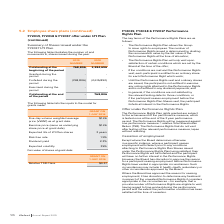According to Iselect's financial document, At which percentile will 50% of LTI Plan shares vest? Based on the financial document, the answer is 50th Percentile. Also, When will the shares vest? Based on the financial document, the answer is if a certain Total Shareholder Return (TSR) relative to the designated comparator group, being the ASX Small Ordinaries Index excluding mining and energy companies, is achieved during the performance period. Also, Which performance measure will the LTI Plans be measured against? relative Total Shareholder Return (TSR). The document states: "will be measured against one performance measure – relative Total Shareholder Return (TSR). The Performance Rights that do not vest after testing of t..." Also, can you calculate: What is the percentage change in the outstanding number of shares at the beginning of the period from 2018 to 2019? To answer this question, I need to perform calculations using the financial data. The calculation is: (768,806-3,384,696)/3,384,696, which equals -77.29 (percentage). This is based on the information: "utstanding at the beginning of the period 768,806 3,384,696 Outstanding at the beginning of the period 768,806 3,384,696..." The key data points involved are: 3,384,696, 768,806. Also, can you calculate: What is the percentage change in the number of forfeited shares during the period from 2018 to 2019? To answer this question, I need to perform calculations using the financial data. The calculation is: (768,806-2,615,890)/2,615,890, which equals -70.61 (percentage). This is based on the information: "Forfeited during the period (768,806) (2,615,890) Forfeited during the period (768,806) (2,615,890)..." The key data points involved are: 2,615,890, 768,806. Additionally, In which year is the number of outstanding shares at the beginning of the period higher? According to the financial document, 2018. The relevant text states: "2019 NUMBER 2018 NUMBER..." 